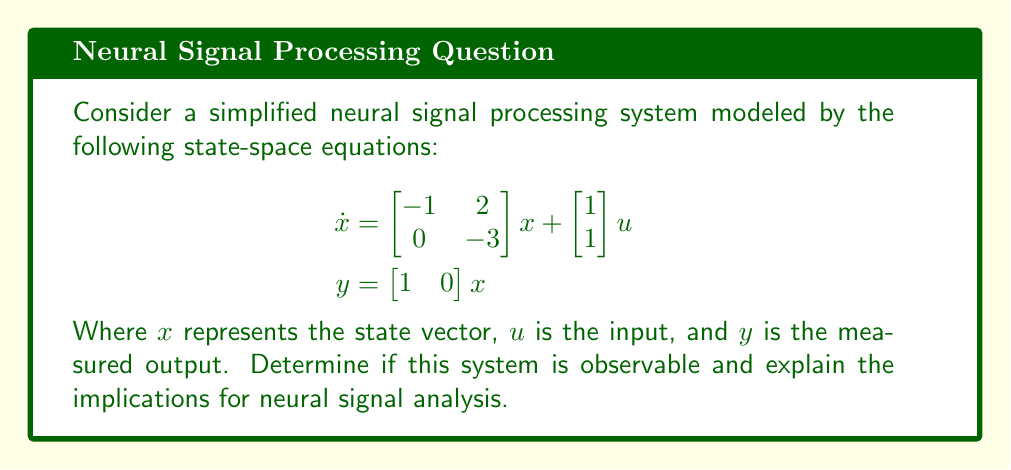Teach me how to tackle this problem. To determine the observability of this neural signal processing system, we need to construct and evaluate the observability matrix. This approach is crucial for understanding whether all states of the neural system can be inferred from its outputs, which is essential for accurate neural signal analysis.

Step 1: Identify the system matrices
From the given state-space equations, we have:
$$A = \begin{bmatrix} -1 & 2 \\ 0 & -3 \end{bmatrix}, \quad C = \begin{bmatrix} 1 & 0 \end{bmatrix}$$

Step 2: Construct the observability matrix
The observability matrix $O$ for a system with $n$ states is given by:
$$O = \begin{bmatrix} C \\ CA \\ CA^2 \\ \vdots \\ CA^{n-1} \end{bmatrix}$$

For our 2-state system:
$$\begin{aligned}
O &= \begin{bmatrix} C \\ CA \end{bmatrix} \\
&= \begin{bmatrix} 1 & 0 \\ -1 & 2 \end{bmatrix}
\end{aligned}$$

Step 3: Evaluate the rank of the observability matrix
For the system to be observable, the rank of $O$ must be equal to the number of states (2 in this case).

The determinant of $O$ is:
$$\det(O) = \begin{vmatrix} 1 & 0 \\ -1 & 2 \end{vmatrix} = 1 \cdot 2 - 0 \cdot (-1) = 2 \neq 0$$

Since the determinant is non-zero, the matrix has full rank (rank = 2), which is equal to the number of states.

Step 4: Interpret the result
The system is observable because the observability matrix has full rank. This means that all states of the neural signal processing system can be determined from the output measurements over time.

Implications for neural signal analysis:
1. Complete state estimation: Researchers can reconstruct all internal states of the neural system from the measured output, allowing for a comprehensive understanding of the neural dynamics.
2. Robust signal processing: Observability ensures that no critical information about the neural system is lost in the measurement process, leading to more reliable analysis and interpretation of neural signals.
3. Improved experimental design: Knowing the system is observable helps in designing more effective experiments and measurement protocols for studying neural activity.
4. Enhanced model validation: The ability to infer all states from measurements allows for better validation and refinement of neural signal processing models.
Answer: The neural signal processing system is observable. This conclusion is based on the full rank (rank = 2) of the observability matrix, which equals the number of states in the system. Observability implies that all internal states of the neural system can be determined from the output measurements, enabling comprehensive analysis and interpretation of neural signals. 